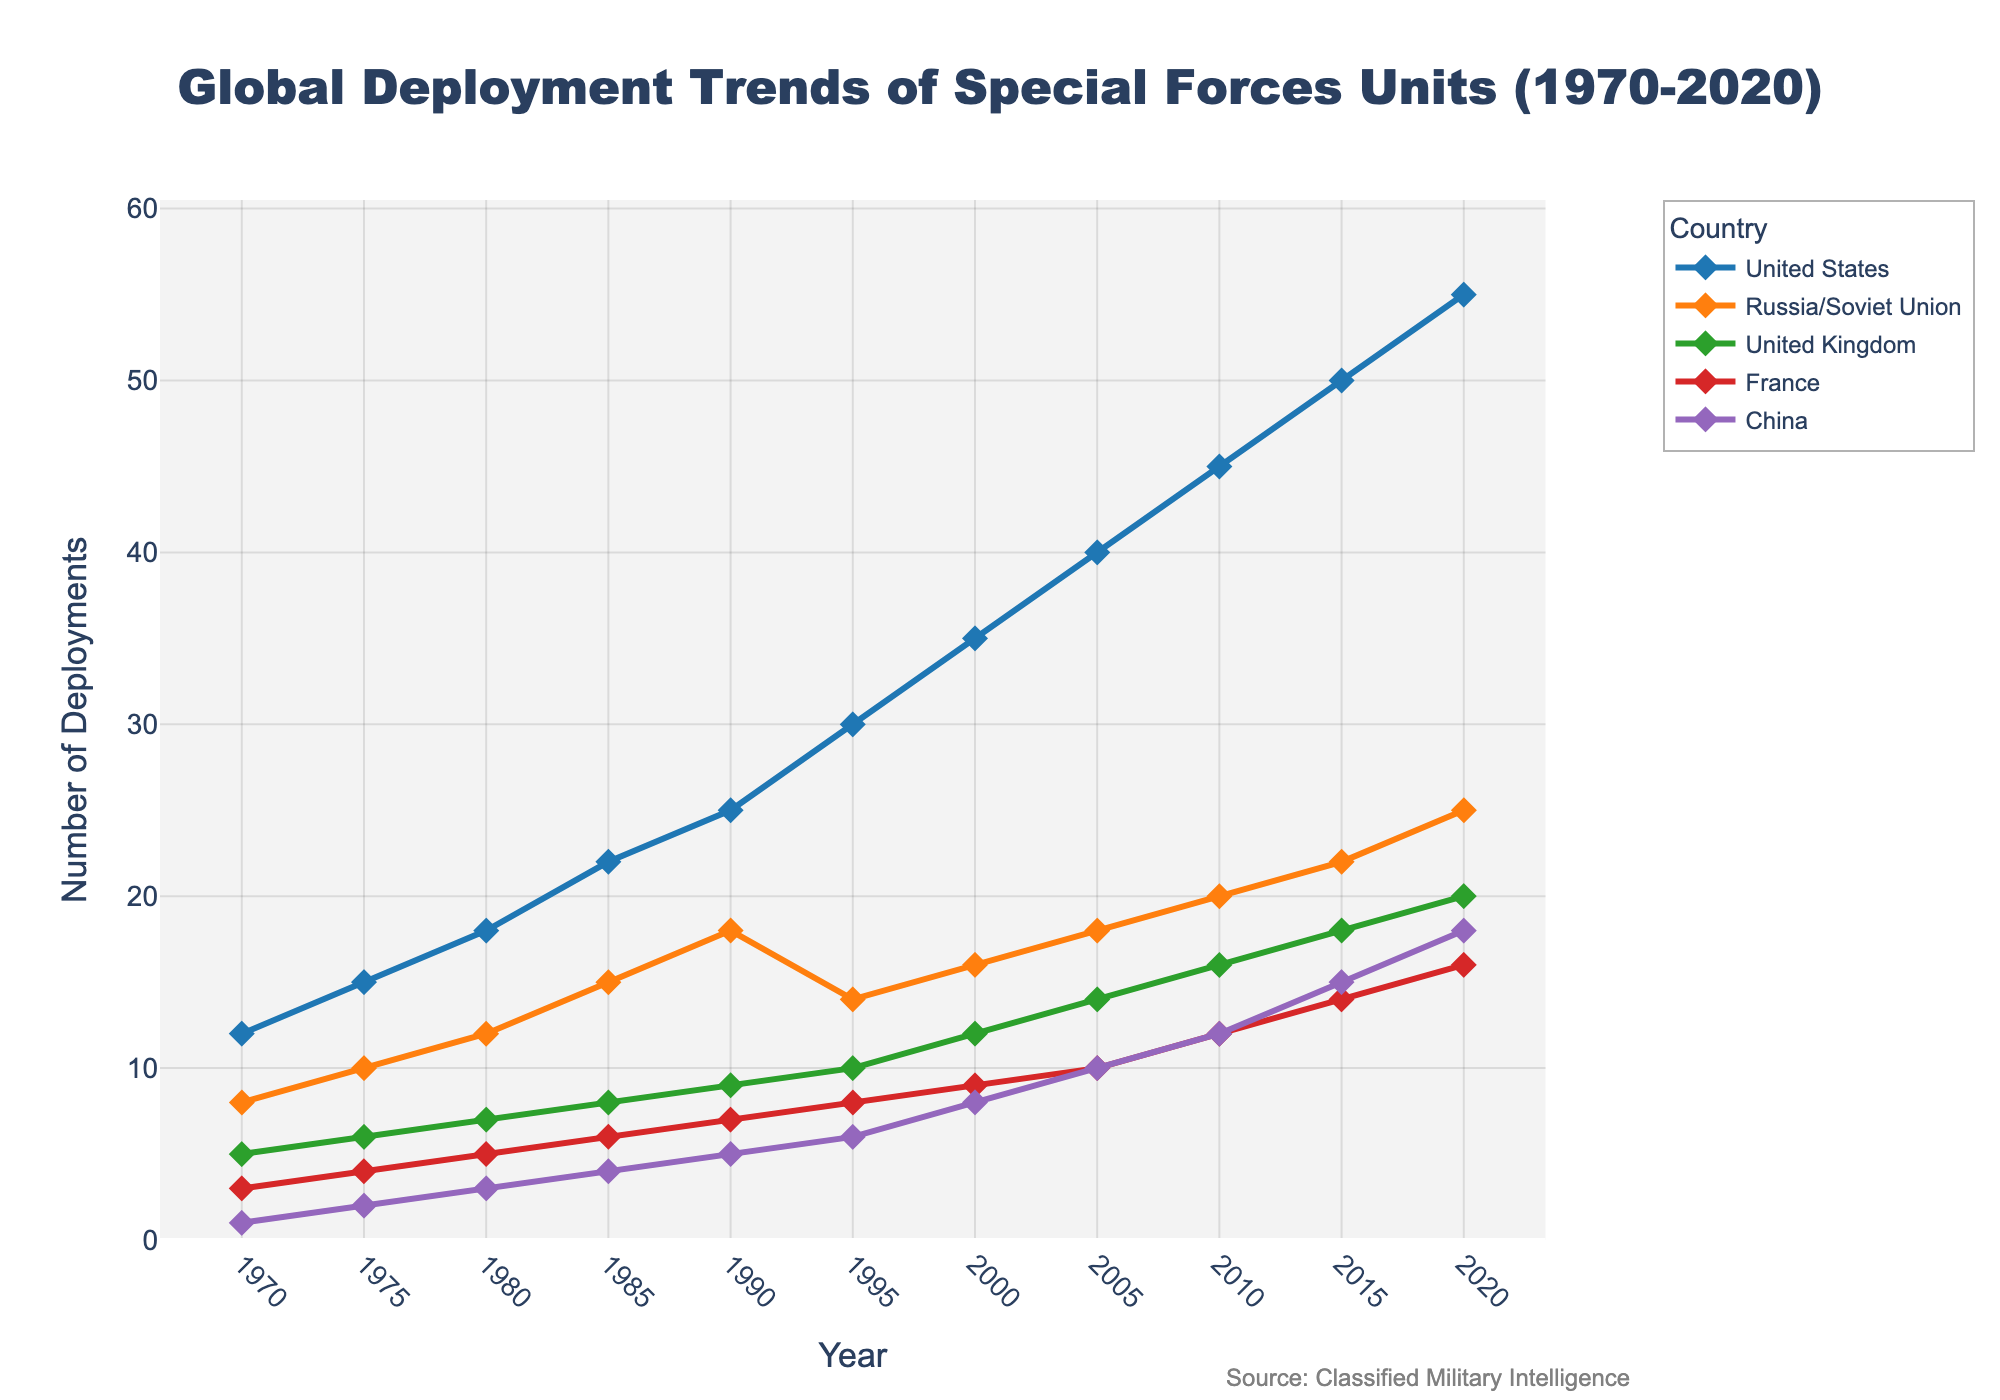What is the total number of deployments for France in the year 2000? The figure shows 9 deployments for France in the year 2000.
Answer: 9 Which country had the highest deployment count in 2020, and what was the count? By observing the figure, the United States had the highest deployments in 2020 with 55 deployments.
Answer: United States, 55 Between which years did China see the most significant increase in deployments? By examining the slope of the line for China, the most significant increase is between 2010 and 2015, where deployments rose from 12 to 15.
Answer: 2010-2015 What is the difference in the number of deployments between Russia/Soviet Union and the United Kingdom in 1995? Using the figure, Russia/Soviet Union had 14 deployments and the United Kingdom had 10 in 1995. Subtracting these gives 14 - 10 = 4.
Answer: 4 Which countries had exactly 10 deployments in any given year, and in what years did this occur? France (1995), United States (1980), United Kingdom (2000) all had 10 deployments as seen in the figure.
Answer: France (1995), United States (1980), United Kingdom (2000) In which year did all five countries have increasing deployments compared to the previous year? By analyzing the graph, 2005 is the year when all five countries show an increase in deployments compared to 2000.
Answer: 2005 Compare the trend of the United Kingdom's deployments with China's from 1970 to 2020. Both countries had an increasing trend over time, but the United Kingdom's deployments rose more steadily compared to China's more significant increases starting around 2005.
Answer: Steady increase for UK, sharper increase post-2005 for China In which years did the United States add an additional five deployments compared to their previous count? According to the figure, this increase happened in increments of 5 deployments in 1990 (from 22), 1995 (from 25), 2000 (from 30), and 2005 (from 35), etc.
Answer: 1990, 1995, 2000, 2005 What is the average number of deployments by France from 1970 to 2020? Adding France's deployments from all years: 3 + 4 + 5 + 6 + 7 + 8 + 9 + 10 + 12 + 14 + 16 = 94. Then dividing by 11 (number of data points) gives 94/11 = approximately 8.55.
Answer: ~8.55 Which country showed the smallest increase in deployments from 1970 to 1980? Observing the figure, France had the smallest increase from 3 to 5, with a difference of 2, compared to other countries' increases.
Answer: France 